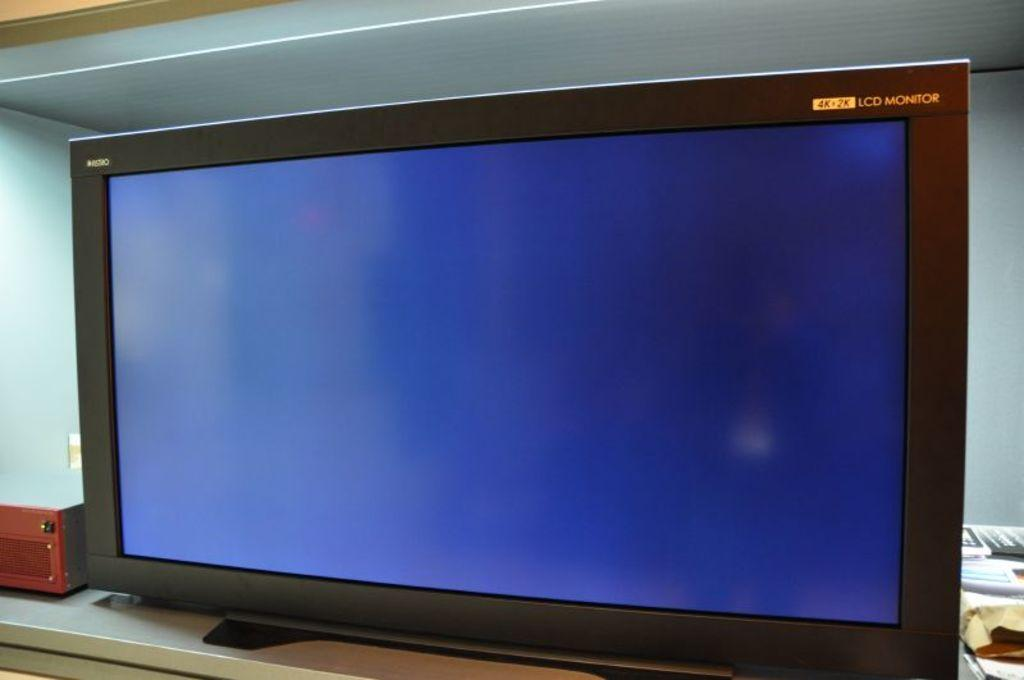<image>
Relay a brief, clear account of the picture shown. 4k & 2k lcd monitor with a blue background on the screen 